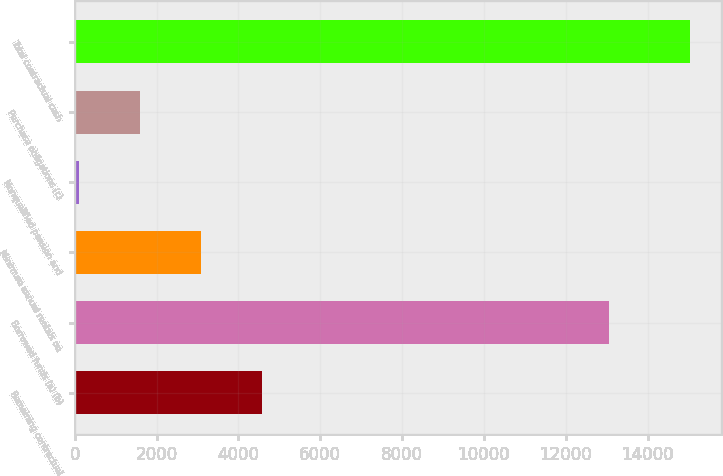Convert chart. <chart><loc_0><loc_0><loc_500><loc_500><bar_chart><fcel>Remaining contractual<fcel>Borrowed funds (a) (b)<fcel>Minimum annual rentals on<fcel>Nonqualified pension and<fcel>Purchase obligations (c)<fcel>Total contractual cash<nl><fcel>4584<fcel>13052<fcel>3090<fcel>102<fcel>1596<fcel>15042<nl></chart> 